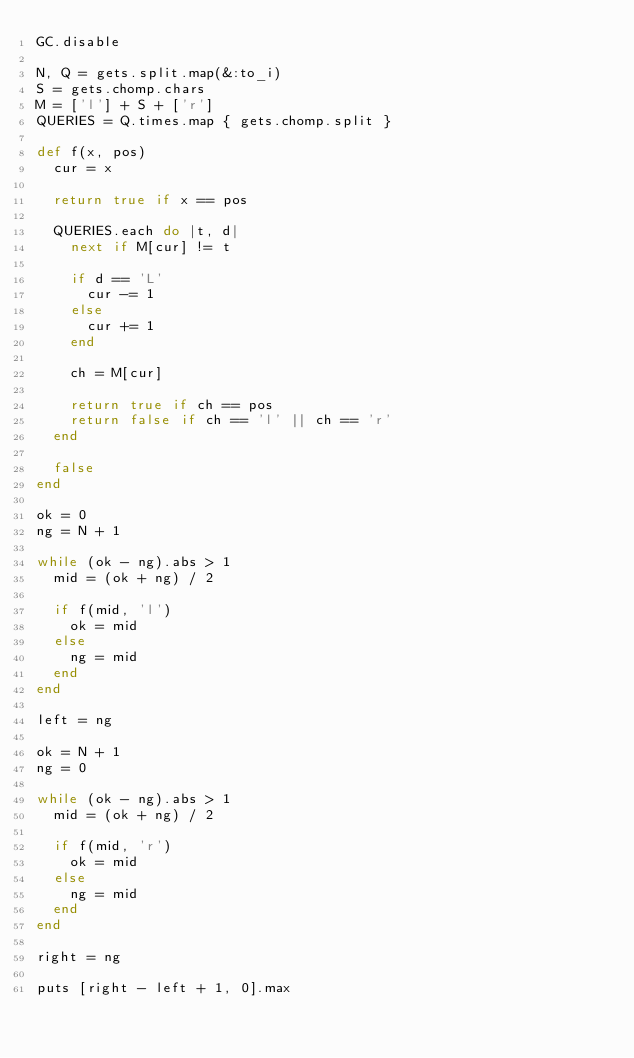<code> <loc_0><loc_0><loc_500><loc_500><_Ruby_>GC.disable

N, Q = gets.split.map(&:to_i)
S = gets.chomp.chars
M = ['l'] + S + ['r']
QUERIES = Q.times.map { gets.chomp.split }

def f(x, pos)
  cur = x

  return true if x == pos

  QUERIES.each do |t, d|
    next if M[cur] != t

    if d == 'L'
      cur -= 1
    else
      cur += 1
    end

    ch = M[cur]

    return true if ch == pos
    return false if ch == 'l' || ch == 'r'
  end

  false
end

ok = 0
ng = N + 1

while (ok - ng).abs > 1
  mid = (ok + ng) / 2

  if f(mid, 'l')
    ok = mid
  else
    ng = mid
  end
end

left = ng

ok = N + 1
ng = 0

while (ok - ng).abs > 1
  mid = (ok + ng) / 2

  if f(mid, 'r')
    ok = mid
  else
    ng = mid
  end
end

right = ng

puts [right - left + 1, 0].max
</code> 